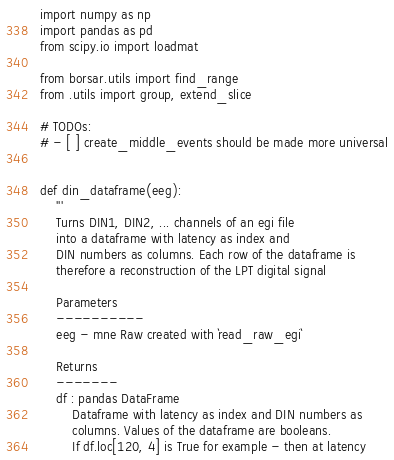<code> <loc_0><loc_0><loc_500><loc_500><_Python_>import numpy as np
import pandas as pd
from scipy.io import loadmat

from borsar.utils import find_range
from .utils import group, extend_slice

# TODOs:
# - [ ] create_middle_events should be made more universal


def din_dataframe(eeg):
	'''
	Turns DIN1, DIN2, ... channels of an egi file
	into a dataframe with latency as index and
	DIN numbers as columns. Each row of the dataframe is
	therefore a reconstruction of the LPT digital signal

	Parameters
	----------
	eeg - mne Raw created with `read_raw_egi`

	Returns
	-------
	df : pandas DataFrame
		Dataframe with latency as index and DIN numbers as
		columns. Values of the dataframe are booleans.
		If df.loc[120, 4] is True for example - then at latency</code> 